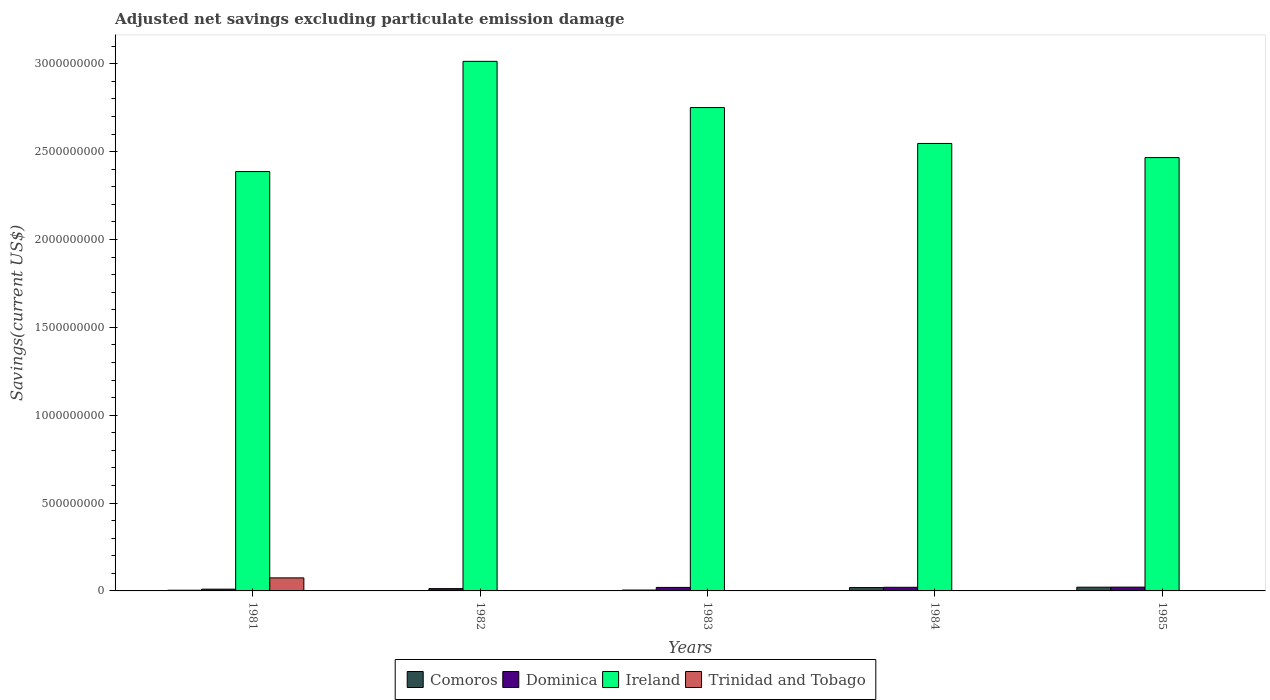How many groups of bars are there?
Offer a terse response. 5. How many bars are there on the 1st tick from the right?
Your answer should be compact. 3. What is the label of the 4th group of bars from the left?
Make the answer very short. 1984. In how many cases, is the number of bars for a given year not equal to the number of legend labels?
Offer a very short reply. 4. What is the adjusted net savings in Ireland in 1981?
Provide a short and direct response. 2.39e+09. Across all years, what is the maximum adjusted net savings in Comoros?
Your answer should be very brief. 2.13e+07. Across all years, what is the minimum adjusted net savings in Comoros?
Provide a succinct answer. 1.66e+06. In which year was the adjusted net savings in Comoros maximum?
Keep it short and to the point. 1985. What is the total adjusted net savings in Dominica in the graph?
Make the answer very short. 8.55e+07. What is the difference between the adjusted net savings in Comoros in 1982 and that in 1984?
Make the answer very short. -1.74e+07. What is the difference between the adjusted net savings in Ireland in 1982 and the adjusted net savings in Dominica in 1984?
Provide a succinct answer. 2.99e+09. What is the average adjusted net savings in Trinidad and Tobago per year?
Offer a very short reply. 1.48e+07. In the year 1985, what is the difference between the adjusted net savings in Comoros and adjusted net savings in Dominica?
Provide a short and direct response. -3.80e+05. In how many years, is the adjusted net savings in Ireland greater than 1700000000 US$?
Provide a short and direct response. 5. What is the ratio of the adjusted net savings in Ireland in 1984 to that in 1985?
Your answer should be very brief. 1.03. Is the adjusted net savings in Comoros in 1982 less than that in 1984?
Your answer should be very brief. Yes. What is the difference between the highest and the second highest adjusted net savings in Comoros?
Make the answer very short. 2.21e+06. What is the difference between the highest and the lowest adjusted net savings in Dominica?
Offer a terse response. 1.16e+07. Is it the case that in every year, the sum of the adjusted net savings in Ireland and adjusted net savings in Trinidad and Tobago is greater than the sum of adjusted net savings in Dominica and adjusted net savings in Comoros?
Provide a short and direct response. Yes. Is it the case that in every year, the sum of the adjusted net savings in Comoros and adjusted net savings in Ireland is greater than the adjusted net savings in Dominica?
Offer a very short reply. Yes. How many bars are there?
Ensure brevity in your answer.  16. Does the graph contain grids?
Provide a succinct answer. No. Where does the legend appear in the graph?
Your answer should be very brief. Bottom center. How are the legend labels stacked?
Provide a short and direct response. Horizontal. What is the title of the graph?
Your answer should be compact. Adjusted net savings excluding particulate emission damage. What is the label or title of the X-axis?
Provide a short and direct response. Years. What is the label or title of the Y-axis?
Make the answer very short. Savings(current US$). What is the Savings(current US$) of Comoros in 1981?
Ensure brevity in your answer.  3.91e+06. What is the Savings(current US$) in Dominica in 1981?
Offer a terse response. 1.00e+07. What is the Savings(current US$) of Ireland in 1981?
Ensure brevity in your answer.  2.39e+09. What is the Savings(current US$) in Trinidad and Tobago in 1981?
Give a very brief answer. 7.42e+07. What is the Savings(current US$) of Comoros in 1982?
Ensure brevity in your answer.  1.66e+06. What is the Savings(current US$) in Dominica in 1982?
Make the answer very short. 1.31e+07. What is the Savings(current US$) in Ireland in 1982?
Make the answer very short. 3.01e+09. What is the Savings(current US$) in Comoros in 1983?
Provide a succinct answer. 5.00e+06. What is the Savings(current US$) in Dominica in 1983?
Ensure brevity in your answer.  2.00e+07. What is the Savings(current US$) in Ireland in 1983?
Your answer should be compact. 2.75e+09. What is the Savings(current US$) in Comoros in 1984?
Offer a terse response. 1.91e+07. What is the Savings(current US$) in Dominica in 1984?
Your answer should be very brief. 2.07e+07. What is the Savings(current US$) of Ireland in 1984?
Provide a short and direct response. 2.55e+09. What is the Savings(current US$) in Trinidad and Tobago in 1984?
Ensure brevity in your answer.  0. What is the Savings(current US$) in Comoros in 1985?
Offer a terse response. 2.13e+07. What is the Savings(current US$) in Dominica in 1985?
Ensure brevity in your answer.  2.17e+07. What is the Savings(current US$) of Ireland in 1985?
Your answer should be very brief. 2.47e+09. Across all years, what is the maximum Savings(current US$) of Comoros?
Your answer should be very brief. 2.13e+07. Across all years, what is the maximum Savings(current US$) of Dominica?
Make the answer very short. 2.17e+07. Across all years, what is the maximum Savings(current US$) in Ireland?
Offer a very short reply. 3.01e+09. Across all years, what is the maximum Savings(current US$) of Trinidad and Tobago?
Give a very brief answer. 7.42e+07. Across all years, what is the minimum Savings(current US$) of Comoros?
Offer a very short reply. 1.66e+06. Across all years, what is the minimum Savings(current US$) in Dominica?
Ensure brevity in your answer.  1.00e+07. Across all years, what is the minimum Savings(current US$) of Ireland?
Your answer should be very brief. 2.39e+09. What is the total Savings(current US$) in Comoros in the graph?
Your answer should be compact. 5.09e+07. What is the total Savings(current US$) in Dominica in the graph?
Your answer should be compact. 8.55e+07. What is the total Savings(current US$) of Ireland in the graph?
Offer a very short reply. 1.32e+1. What is the total Savings(current US$) in Trinidad and Tobago in the graph?
Ensure brevity in your answer.  7.42e+07. What is the difference between the Savings(current US$) in Comoros in 1981 and that in 1982?
Provide a succinct answer. 2.25e+06. What is the difference between the Savings(current US$) in Dominica in 1981 and that in 1982?
Make the answer very short. -3.10e+06. What is the difference between the Savings(current US$) of Ireland in 1981 and that in 1982?
Offer a very short reply. -6.27e+08. What is the difference between the Savings(current US$) in Comoros in 1981 and that in 1983?
Make the answer very short. -1.09e+06. What is the difference between the Savings(current US$) in Dominica in 1981 and that in 1983?
Offer a very short reply. -9.99e+06. What is the difference between the Savings(current US$) in Ireland in 1981 and that in 1983?
Offer a very short reply. -3.64e+08. What is the difference between the Savings(current US$) of Comoros in 1981 and that in 1984?
Offer a terse response. -1.52e+07. What is the difference between the Savings(current US$) of Dominica in 1981 and that in 1984?
Your answer should be very brief. -1.07e+07. What is the difference between the Savings(current US$) in Ireland in 1981 and that in 1984?
Your answer should be compact. -1.60e+08. What is the difference between the Savings(current US$) in Comoros in 1981 and that in 1985?
Your response must be concise. -1.74e+07. What is the difference between the Savings(current US$) of Dominica in 1981 and that in 1985?
Ensure brevity in your answer.  -1.16e+07. What is the difference between the Savings(current US$) of Ireland in 1981 and that in 1985?
Make the answer very short. -7.95e+07. What is the difference between the Savings(current US$) of Comoros in 1982 and that in 1983?
Keep it short and to the point. -3.34e+06. What is the difference between the Savings(current US$) in Dominica in 1982 and that in 1983?
Make the answer very short. -6.89e+06. What is the difference between the Savings(current US$) in Ireland in 1982 and that in 1983?
Your answer should be compact. 2.63e+08. What is the difference between the Savings(current US$) in Comoros in 1982 and that in 1984?
Provide a succinct answer. -1.74e+07. What is the difference between the Savings(current US$) in Dominica in 1982 and that in 1984?
Give a very brief answer. -7.58e+06. What is the difference between the Savings(current US$) of Ireland in 1982 and that in 1984?
Provide a succinct answer. 4.67e+08. What is the difference between the Savings(current US$) of Comoros in 1982 and that in 1985?
Make the answer very short. -1.96e+07. What is the difference between the Savings(current US$) of Dominica in 1982 and that in 1985?
Give a very brief answer. -8.55e+06. What is the difference between the Savings(current US$) in Ireland in 1982 and that in 1985?
Your answer should be compact. 5.48e+08. What is the difference between the Savings(current US$) in Comoros in 1983 and that in 1984?
Offer a very short reply. -1.41e+07. What is the difference between the Savings(current US$) of Dominica in 1983 and that in 1984?
Keep it short and to the point. -6.91e+05. What is the difference between the Savings(current US$) in Ireland in 1983 and that in 1984?
Ensure brevity in your answer.  2.04e+08. What is the difference between the Savings(current US$) of Comoros in 1983 and that in 1985?
Provide a succinct answer. -1.63e+07. What is the difference between the Savings(current US$) in Dominica in 1983 and that in 1985?
Ensure brevity in your answer.  -1.65e+06. What is the difference between the Savings(current US$) of Ireland in 1983 and that in 1985?
Offer a very short reply. 2.85e+08. What is the difference between the Savings(current US$) of Comoros in 1984 and that in 1985?
Your response must be concise. -2.21e+06. What is the difference between the Savings(current US$) of Dominica in 1984 and that in 1985?
Give a very brief answer. -9.62e+05. What is the difference between the Savings(current US$) of Ireland in 1984 and that in 1985?
Give a very brief answer. 8.04e+07. What is the difference between the Savings(current US$) of Comoros in 1981 and the Savings(current US$) of Dominica in 1982?
Keep it short and to the point. -9.20e+06. What is the difference between the Savings(current US$) of Comoros in 1981 and the Savings(current US$) of Ireland in 1982?
Give a very brief answer. -3.01e+09. What is the difference between the Savings(current US$) in Dominica in 1981 and the Savings(current US$) in Ireland in 1982?
Offer a very short reply. -3.00e+09. What is the difference between the Savings(current US$) of Comoros in 1981 and the Savings(current US$) of Dominica in 1983?
Your answer should be compact. -1.61e+07. What is the difference between the Savings(current US$) in Comoros in 1981 and the Savings(current US$) in Ireland in 1983?
Offer a very short reply. -2.75e+09. What is the difference between the Savings(current US$) in Dominica in 1981 and the Savings(current US$) in Ireland in 1983?
Your response must be concise. -2.74e+09. What is the difference between the Savings(current US$) in Comoros in 1981 and the Savings(current US$) in Dominica in 1984?
Make the answer very short. -1.68e+07. What is the difference between the Savings(current US$) in Comoros in 1981 and the Savings(current US$) in Ireland in 1984?
Keep it short and to the point. -2.54e+09. What is the difference between the Savings(current US$) of Dominica in 1981 and the Savings(current US$) of Ireland in 1984?
Provide a succinct answer. -2.54e+09. What is the difference between the Savings(current US$) of Comoros in 1981 and the Savings(current US$) of Dominica in 1985?
Keep it short and to the point. -1.77e+07. What is the difference between the Savings(current US$) in Comoros in 1981 and the Savings(current US$) in Ireland in 1985?
Ensure brevity in your answer.  -2.46e+09. What is the difference between the Savings(current US$) of Dominica in 1981 and the Savings(current US$) of Ireland in 1985?
Provide a succinct answer. -2.46e+09. What is the difference between the Savings(current US$) of Comoros in 1982 and the Savings(current US$) of Dominica in 1983?
Keep it short and to the point. -1.83e+07. What is the difference between the Savings(current US$) in Comoros in 1982 and the Savings(current US$) in Ireland in 1983?
Provide a succinct answer. -2.75e+09. What is the difference between the Savings(current US$) of Dominica in 1982 and the Savings(current US$) of Ireland in 1983?
Provide a short and direct response. -2.74e+09. What is the difference between the Savings(current US$) of Comoros in 1982 and the Savings(current US$) of Dominica in 1984?
Make the answer very short. -1.90e+07. What is the difference between the Savings(current US$) of Comoros in 1982 and the Savings(current US$) of Ireland in 1984?
Your answer should be compact. -2.54e+09. What is the difference between the Savings(current US$) in Dominica in 1982 and the Savings(current US$) in Ireland in 1984?
Make the answer very short. -2.53e+09. What is the difference between the Savings(current US$) of Comoros in 1982 and the Savings(current US$) of Dominica in 1985?
Your response must be concise. -2.00e+07. What is the difference between the Savings(current US$) in Comoros in 1982 and the Savings(current US$) in Ireland in 1985?
Make the answer very short. -2.46e+09. What is the difference between the Savings(current US$) in Dominica in 1982 and the Savings(current US$) in Ireland in 1985?
Make the answer very short. -2.45e+09. What is the difference between the Savings(current US$) of Comoros in 1983 and the Savings(current US$) of Dominica in 1984?
Offer a very short reply. -1.57e+07. What is the difference between the Savings(current US$) in Comoros in 1983 and the Savings(current US$) in Ireland in 1984?
Your answer should be very brief. -2.54e+09. What is the difference between the Savings(current US$) of Dominica in 1983 and the Savings(current US$) of Ireland in 1984?
Keep it short and to the point. -2.53e+09. What is the difference between the Savings(current US$) of Comoros in 1983 and the Savings(current US$) of Dominica in 1985?
Your response must be concise. -1.67e+07. What is the difference between the Savings(current US$) of Comoros in 1983 and the Savings(current US$) of Ireland in 1985?
Offer a terse response. -2.46e+09. What is the difference between the Savings(current US$) of Dominica in 1983 and the Savings(current US$) of Ireland in 1985?
Make the answer very short. -2.45e+09. What is the difference between the Savings(current US$) of Comoros in 1984 and the Savings(current US$) of Dominica in 1985?
Offer a terse response. -2.59e+06. What is the difference between the Savings(current US$) of Comoros in 1984 and the Savings(current US$) of Ireland in 1985?
Your answer should be very brief. -2.45e+09. What is the difference between the Savings(current US$) in Dominica in 1984 and the Savings(current US$) in Ireland in 1985?
Make the answer very short. -2.45e+09. What is the average Savings(current US$) in Comoros per year?
Keep it short and to the point. 1.02e+07. What is the average Savings(current US$) in Dominica per year?
Provide a succinct answer. 1.71e+07. What is the average Savings(current US$) in Ireland per year?
Provide a succinct answer. 2.63e+09. What is the average Savings(current US$) in Trinidad and Tobago per year?
Offer a very short reply. 1.48e+07. In the year 1981, what is the difference between the Savings(current US$) of Comoros and Savings(current US$) of Dominica?
Your answer should be very brief. -6.10e+06. In the year 1981, what is the difference between the Savings(current US$) in Comoros and Savings(current US$) in Ireland?
Give a very brief answer. -2.38e+09. In the year 1981, what is the difference between the Savings(current US$) of Comoros and Savings(current US$) of Trinidad and Tobago?
Offer a terse response. -7.03e+07. In the year 1981, what is the difference between the Savings(current US$) of Dominica and Savings(current US$) of Ireland?
Make the answer very short. -2.38e+09. In the year 1981, what is the difference between the Savings(current US$) in Dominica and Savings(current US$) in Trinidad and Tobago?
Offer a terse response. -6.42e+07. In the year 1981, what is the difference between the Savings(current US$) in Ireland and Savings(current US$) in Trinidad and Tobago?
Provide a short and direct response. 2.31e+09. In the year 1982, what is the difference between the Savings(current US$) in Comoros and Savings(current US$) in Dominica?
Keep it short and to the point. -1.14e+07. In the year 1982, what is the difference between the Savings(current US$) of Comoros and Savings(current US$) of Ireland?
Ensure brevity in your answer.  -3.01e+09. In the year 1982, what is the difference between the Savings(current US$) of Dominica and Savings(current US$) of Ireland?
Offer a terse response. -3.00e+09. In the year 1983, what is the difference between the Savings(current US$) of Comoros and Savings(current US$) of Dominica?
Your answer should be compact. -1.50e+07. In the year 1983, what is the difference between the Savings(current US$) of Comoros and Savings(current US$) of Ireland?
Ensure brevity in your answer.  -2.75e+09. In the year 1983, what is the difference between the Savings(current US$) in Dominica and Savings(current US$) in Ireland?
Offer a terse response. -2.73e+09. In the year 1984, what is the difference between the Savings(current US$) in Comoros and Savings(current US$) in Dominica?
Ensure brevity in your answer.  -1.63e+06. In the year 1984, what is the difference between the Savings(current US$) of Comoros and Savings(current US$) of Ireland?
Provide a succinct answer. -2.53e+09. In the year 1984, what is the difference between the Savings(current US$) in Dominica and Savings(current US$) in Ireland?
Provide a short and direct response. -2.53e+09. In the year 1985, what is the difference between the Savings(current US$) of Comoros and Savings(current US$) of Dominica?
Offer a terse response. -3.80e+05. In the year 1985, what is the difference between the Savings(current US$) in Comoros and Savings(current US$) in Ireland?
Offer a very short reply. -2.44e+09. In the year 1985, what is the difference between the Savings(current US$) in Dominica and Savings(current US$) in Ireland?
Provide a succinct answer. -2.44e+09. What is the ratio of the Savings(current US$) in Comoros in 1981 to that in 1982?
Your answer should be compact. 2.36. What is the ratio of the Savings(current US$) in Dominica in 1981 to that in 1982?
Make the answer very short. 0.76. What is the ratio of the Savings(current US$) of Ireland in 1981 to that in 1982?
Provide a succinct answer. 0.79. What is the ratio of the Savings(current US$) of Comoros in 1981 to that in 1983?
Your answer should be compact. 0.78. What is the ratio of the Savings(current US$) in Dominica in 1981 to that in 1983?
Provide a succinct answer. 0.5. What is the ratio of the Savings(current US$) of Ireland in 1981 to that in 1983?
Your answer should be compact. 0.87. What is the ratio of the Savings(current US$) in Comoros in 1981 to that in 1984?
Your answer should be very brief. 0.21. What is the ratio of the Savings(current US$) in Dominica in 1981 to that in 1984?
Provide a short and direct response. 0.48. What is the ratio of the Savings(current US$) in Ireland in 1981 to that in 1984?
Your response must be concise. 0.94. What is the ratio of the Savings(current US$) of Comoros in 1981 to that in 1985?
Provide a short and direct response. 0.18. What is the ratio of the Savings(current US$) of Dominica in 1981 to that in 1985?
Your answer should be compact. 0.46. What is the ratio of the Savings(current US$) in Ireland in 1981 to that in 1985?
Provide a succinct answer. 0.97. What is the ratio of the Savings(current US$) of Comoros in 1982 to that in 1983?
Offer a very short reply. 0.33. What is the ratio of the Savings(current US$) in Dominica in 1982 to that in 1983?
Your answer should be compact. 0.66. What is the ratio of the Savings(current US$) in Ireland in 1982 to that in 1983?
Give a very brief answer. 1.1. What is the ratio of the Savings(current US$) of Comoros in 1982 to that in 1984?
Your answer should be compact. 0.09. What is the ratio of the Savings(current US$) of Dominica in 1982 to that in 1984?
Ensure brevity in your answer.  0.63. What is the ratio of the Savings(current US$) in Ireland in 1982 to that in 1984?
Your answer should be very brief. 1.18. What is the ratio of the Savings(current US$) of Comoros in 1982 to that in 1985?
Provide a succinct answer. 0.08. What is the ratio of the Savings(current US$) of Dominica in 1982 to that in 1985?
Offer a terse response. 0.61. What is the ratio of the Savings(current US$) of Ireland in 1982 to that in 1985?
Ensure brevity in your answer.  1.22. What is the ratio of the Savings(current US$) in Comoros in 1983 to that in 1984?
Keep it short and to the point. 0.26. What is the ratio of the Savings(current US$) in Dominica in 1983 to that in 1984?
Give a very brief answer. 0.97. What is the ratio of the Savings(current US$) of Ireland in 1983 to that in 1984?
Offer a terse response. 1.08. What is the ratio of the Savings(current US$) in Comoros in 1983 to that in 1985?
Your answer should be very brief. 0.24. What is the ratio of the Savings(current US$) in Dominica in 1983 to that in 1985?
Give a very brief answer. 0.92. What is the ratio of the Savings(current US$) of Ireland in 1983 to that in 1985?
Give a very brief answer. 1.12. What is the ratio of the Savings(current US$) in Comoros in 1984 to that in 1985?
Your answer should be very brief. 0.9. What is the ratio of the Savings(current US$) in Dominica in 1984 to that in 1985?
Give a very brief answer. 0.96. What is the ratio of the Savings(current US$) of Ireland in 1984 to that in 1985?
Ensure brevity in your answer.  1.03. What is the difference between the highest and the second highest Savings(current US$) of Comoros?
Offer a very short reply. 2.21e+06. What is the difference between the highest and the second highest Savings(current US$) of Dominica?
Your answer should be very brief. 9.62e+05. What is the difference between the highest and the second highest Savings(current US$) in Ireland?
Your answer should be compact. 2.63e+08. What is the difference between the highest and the lowest Savings(current US$) of Comoros?
Provide a succinct answer. 1.96e+07. What is the difference between the highest and the lowest Savings(current US$) in Dominica?
Offer a terse response. 1.16e+07. What is the difference between the highest and the lowest Savings(current US$) in Ireland?
Provide a short and direct response. 6.27e+08. What is the difference between the highest and the lowest Savings(current US$) of Trinidad and Tobago?
Make the answer very short. 7.42e+07. 